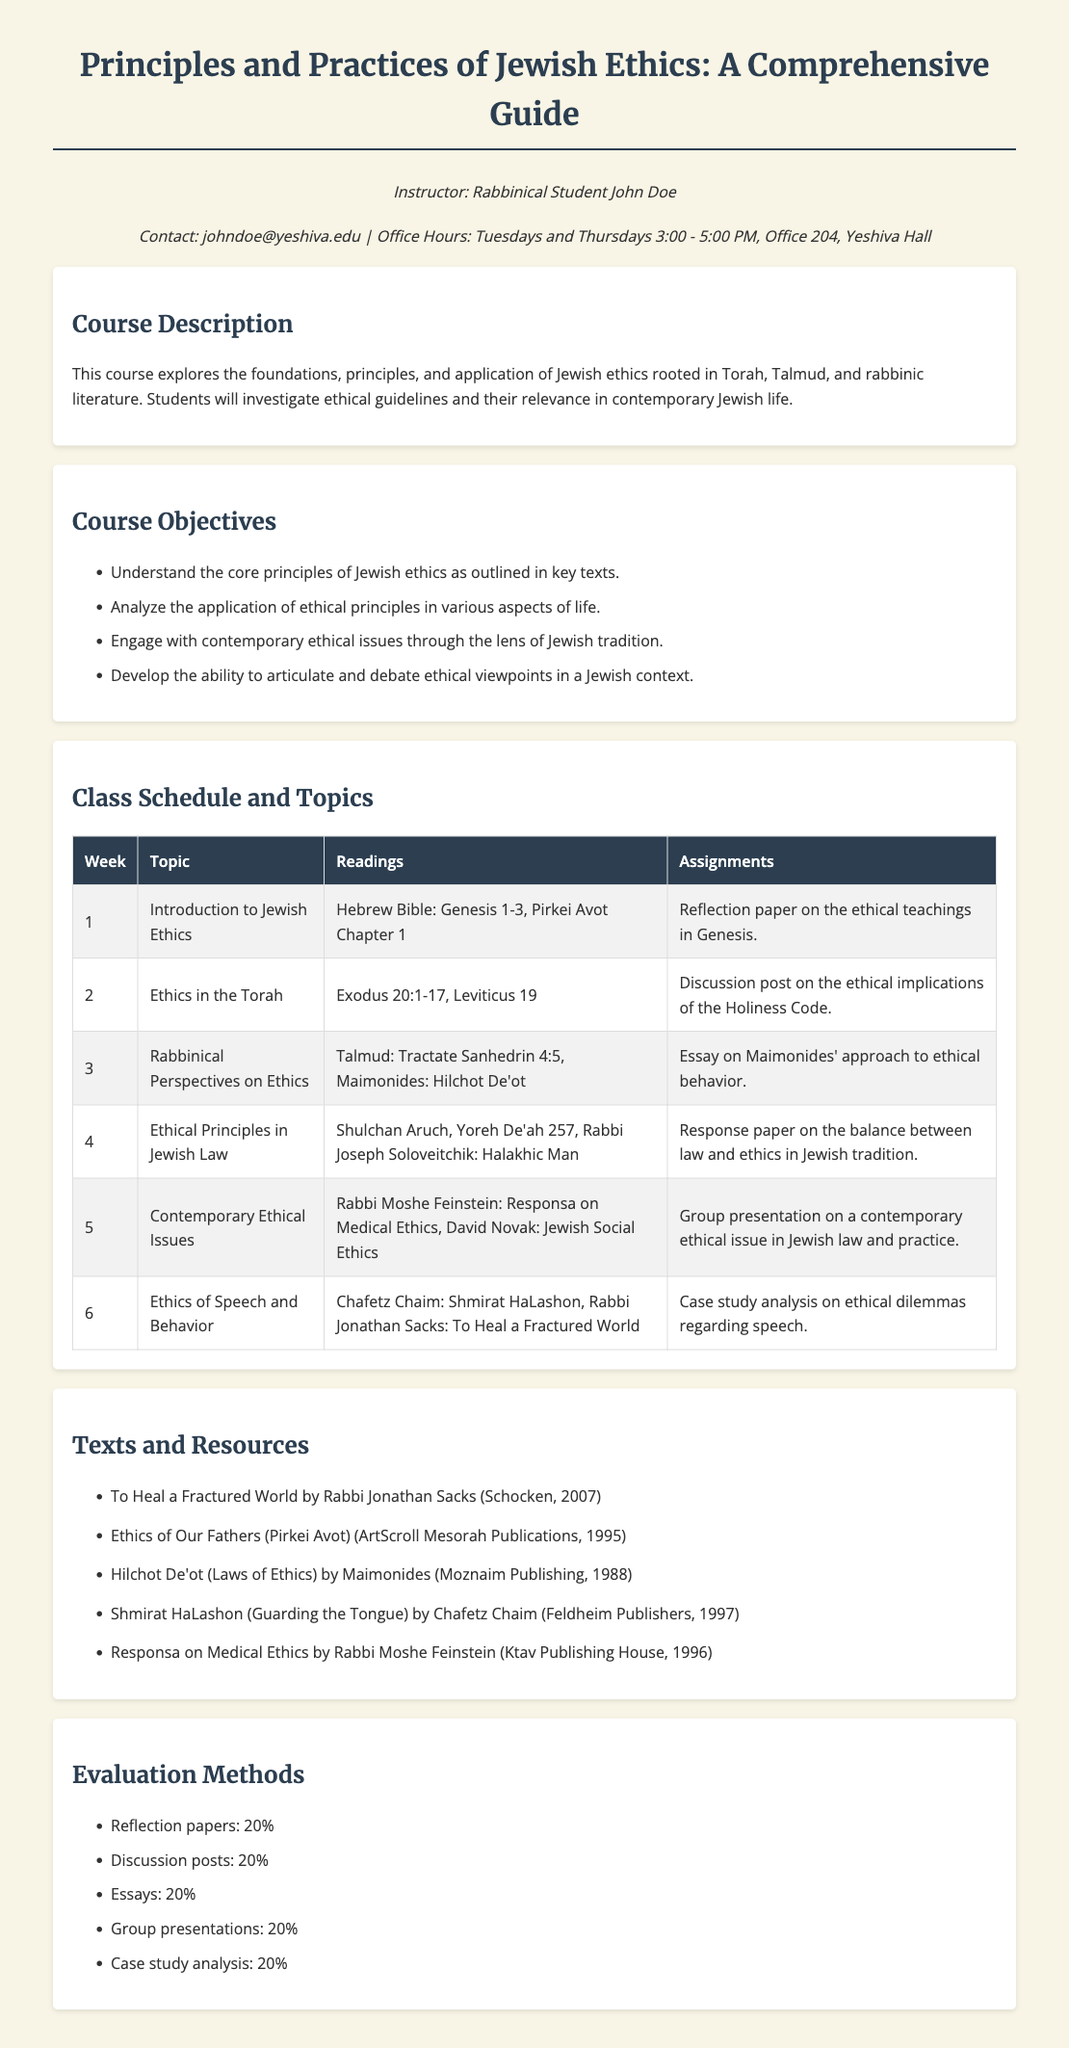What is the title of the course? The title is presented at the top of the syllabus and is "Principles and Practices of Jewish Ethics: A Comprehensive Guide."
Answer: Principles and Practices of Jewish Ethics: A Comprehensive Guide Who is the instructor of the course? The course includes an instructor's name, which is "Rabbinical Student John Doe."
Answer: Rabbinical Student John Doe What is the percentage weight of reflection papers in the evaluation? The evaluation methods section lists weightings for various assignments, with reflection papers assigned 20%.
Answer: 20% In which week is the topic "Ethics of Speech and Behavior" covered? The class schedule provides weekly topics, with the mentioned topic covered in week 6.
Answer: 6 What readings are assigned for the "Ethics in the Torah" topic? Each week's topic specifies required readings, with Exodus 20:1-17 and Leviticus 19 assigned for this topic.
Answer: Exodus 20:1-17, Leviticus 19 Which book by Rabbi Jonathan Sacks is listed as a resource? The texts and resources section lists various materials, including "To Heal a Fractured World" by Rabbi Jonathan Sacks.
Answer: To Heal a Fractured World What type of analysis is assigned for week 6? The assignments for week 6 include a case study analysis related to ethical dilemmas regarding speech.
Answer: Case study analysis What is the total number of topics covered in the course schedule? The document lists weekly topics from weeks 1 to 6, indicating a total of six topics for the course.
Answer: 6 